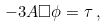<formula> <loc_0><loc_0><loc_500><loc_500>- 3 A \Box \phi = \tau \, ,</formula> 